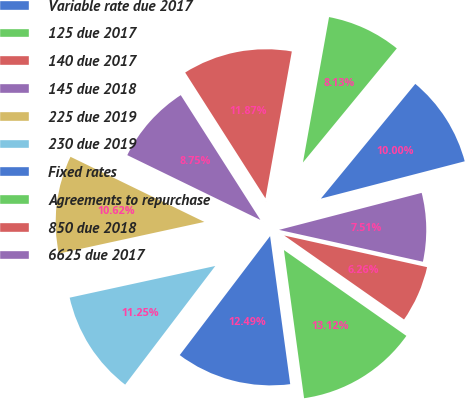Convert chart. <chart><loc_0><loc_0><loc_500><loc_500><pie_chart><fcel>Variable rate due 2017<fcel>125 due 2017<fcel>140 due 2017<fcel>145 due 2018<fcel>225 due 2019<fcel>230 due 2019<fcel>Fixed rates<fcel>Agreements to repurchase<fcel>850 due 2018<fcel>6625 due 2017<nl><fcel>10.0%<fcel>8.13%<fcel>11.87%<fcel>8.75%<fcel>10.62%<fcel>11.25%<fcel>12.49%<fcel>13.12%<fcel>6.26%<fcel>7.51%<nl></chart> 